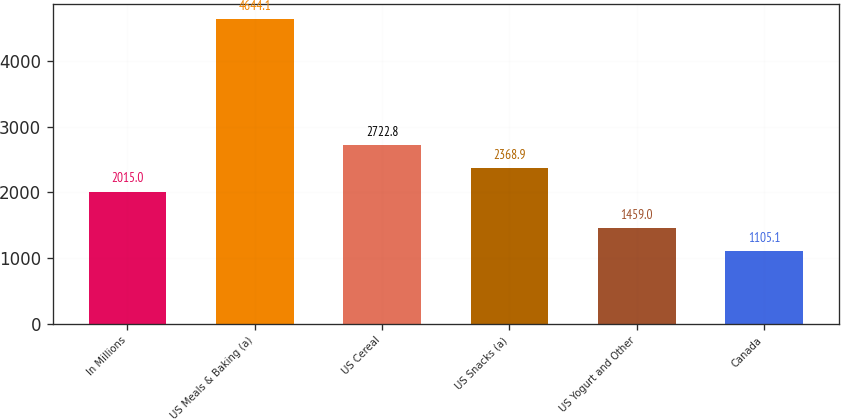Convert chart. <chart><loc_0><loc_0><loc_500><loc_500><bar_chart><fcel>In Millions<fcel>US Meals & Baking (a)<fcel>US Cereal<fcel>US Snacks (a)<fcel>US Yogurt and Other<fcel>Canada<nl><fcel>2015<fcel>4644.1<fcel>2722.8<fcel>2368.9<fcel>1459<fcel>1105.1<nl></chart> 